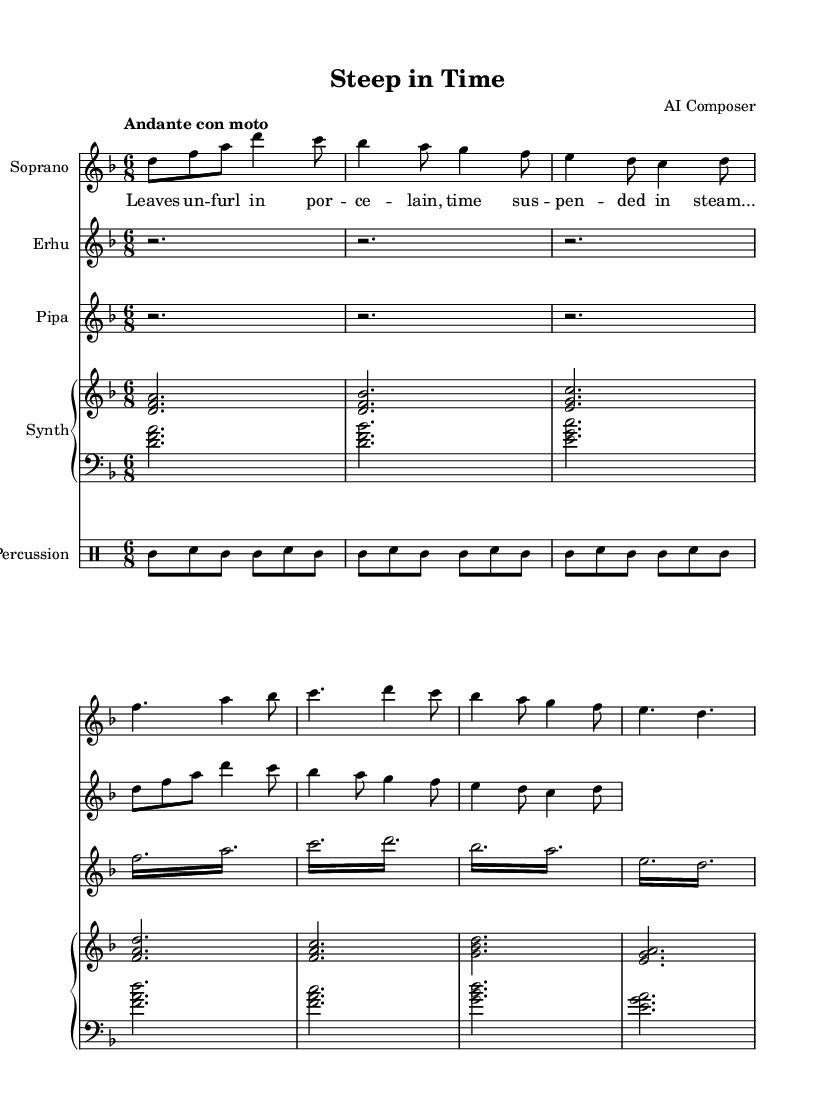What is the key signature of this music? The key signature is D minor, indicated by one flat (B flat) at the beginning of the staff.
Answer: D minor What is the time signature of this piece? The time signature is 6/8, which is shown at the beginning of each staff and indicates a compound duple meter with six eighth notes per measure.
Answer: 6/8 What is the tempo marking given for the opera? The tempo marking is "Andante con moto," meaning at a moderate pace with motion, as specified at the beginning of the sheet music.
Answer: Andante con moto How many measures are in the soprano voice section? There are eight measures in the soprano voice section as counted from the beginning to the end of the provided music notation.
Answer: Eight Which instruments are included in this arrangement? The instruments included are Soprano, Erhu, Pipa, Synth, and Percussion, as indicated by the staff titles at the beginning of each instrument's section.
Answer: Soprano, Erhu, Pipa, Synth, Percussion What type of musical embellishment is used in the Pipa section? The Pipa section uses tremolo, indicated by the repeated notation of sixteenth notes, suggesting a rapid oscillation effect typical in traditional Chinese music.
Answer: Tremolo How does the erhu music begin? The erhu music begins with three measure rests where no notes are played, indicated by "r2." This establishes a quiet beginning before the melody starts.
Answer: Three measure rests 